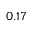<formula> <loc_0><loc_0><loc_500><loc_500>0 . 1 7</formula> 